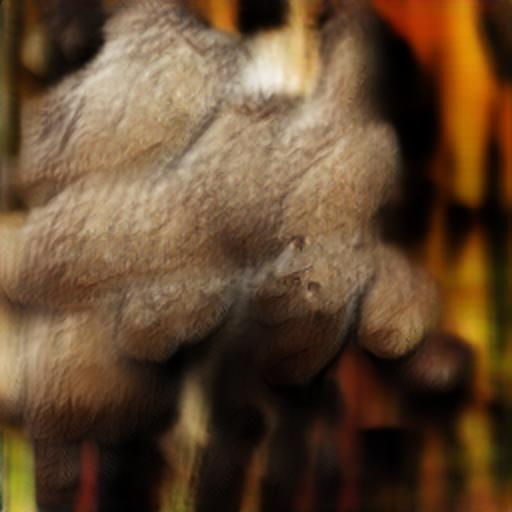What feeling does this image immediately invoke? The blurring effect and warm tones of the image create a feeling of nostalgia or memory, as though the viewer is recalling a moment with affection but through a hazy recollection. 